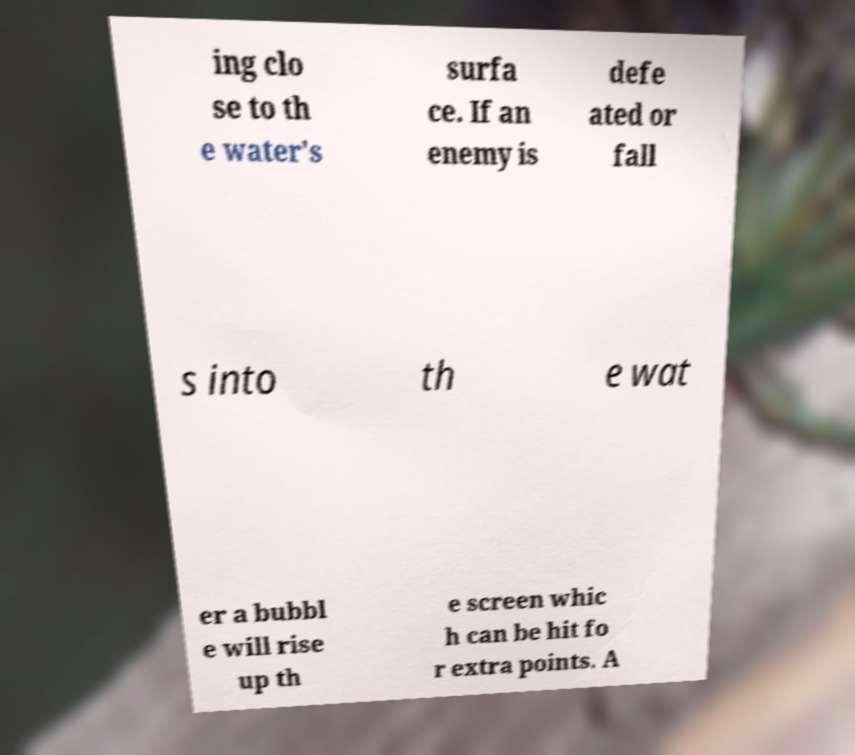Can you read and provide the text displayed in the image?This photo seems to have some interesting text. Can you extract and type it out for me? ing clo se to th e water's surfa ce. If an enemy is defe ated or fall s into th e wat er a bubbl e will rise up th e screen whic h can be hit fo r extra points. A 